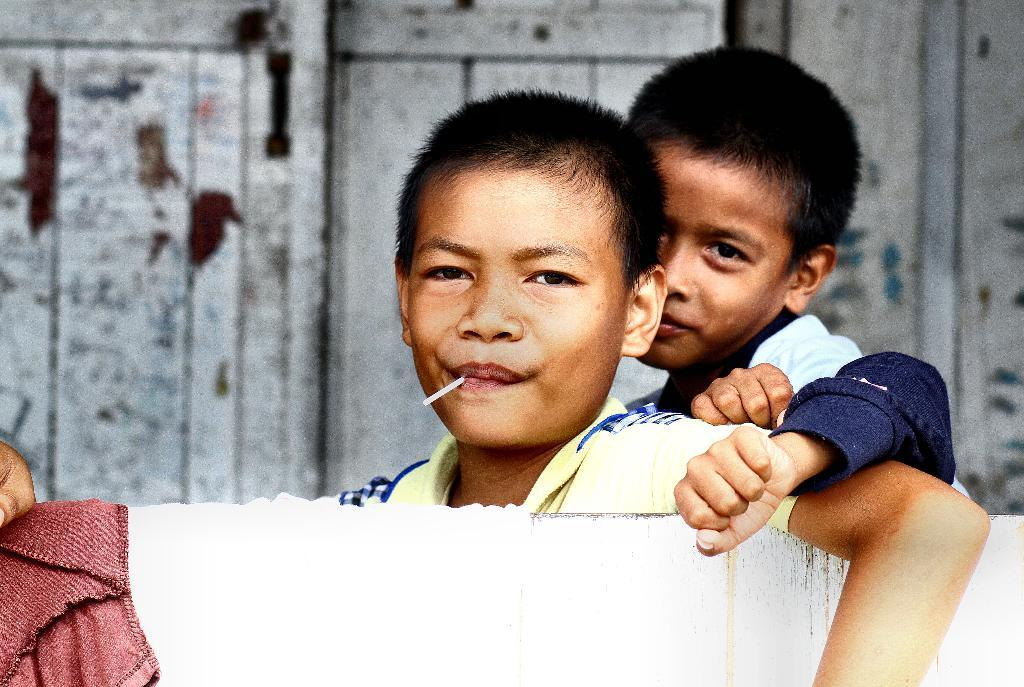How many people are in the image? There are two people in the image. What can be seen behind the people in the image? The two people are behind a wooden wall. What is hanging on the wooden wall in the image? There is a cloth on the wall in the image. What feature of the wall suggests an entrance or exit? There is a door in the image. Where is the airport located in the image? There is no airport present in the image. What type of attraction is depicted in the image? The image does not depict any specific attraction; it features two people behind a wooden wall. 